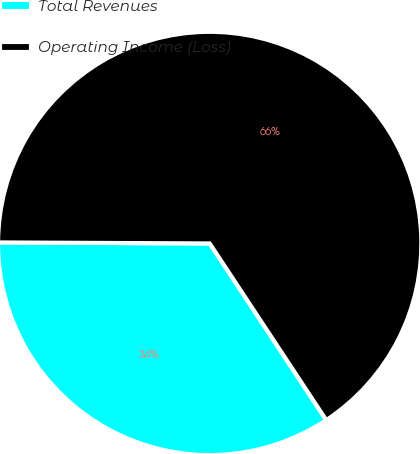Convert chart to OTSL. <chart><loc_0><loc_0><loc_500><loc_500><pie_chart><fcel>Total Revenues<fcel>Operating Income (Loss)<nl><fcel>34.36%<fcel>65.64%<nl></chart> 